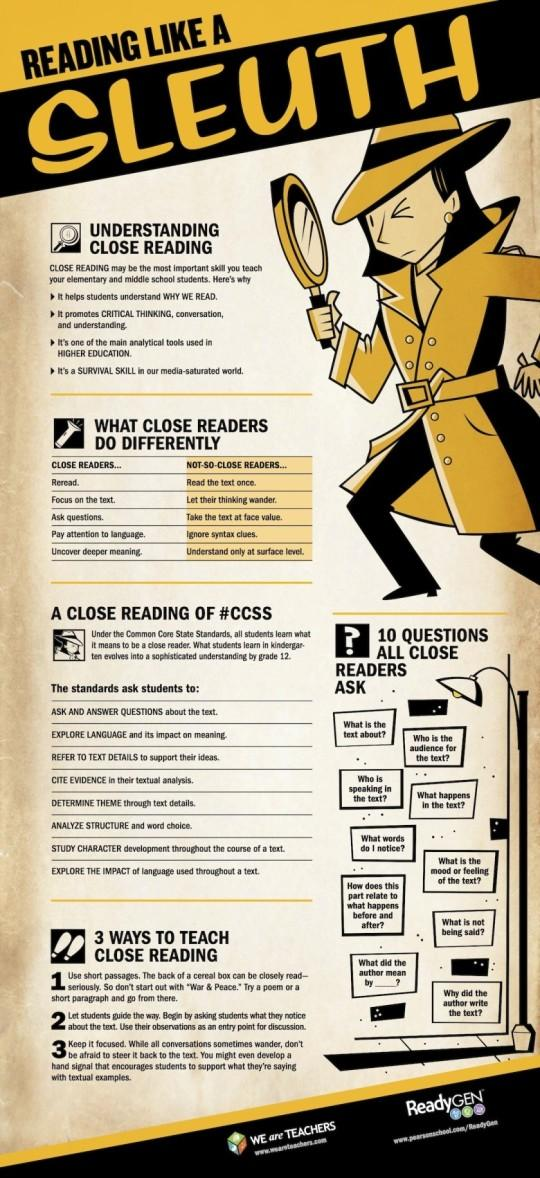Mention a couple of crucial points in this snapshot. I declare that those who allow their thoughts to wander are not-so-close readers. Close reading is a critical thinking promoting technique. Close readers are the ones who pay attention to language. Who ignores syntax clues? Not-so-close readers, they are. After close reading, it has been identified that there are 4 benefits. 